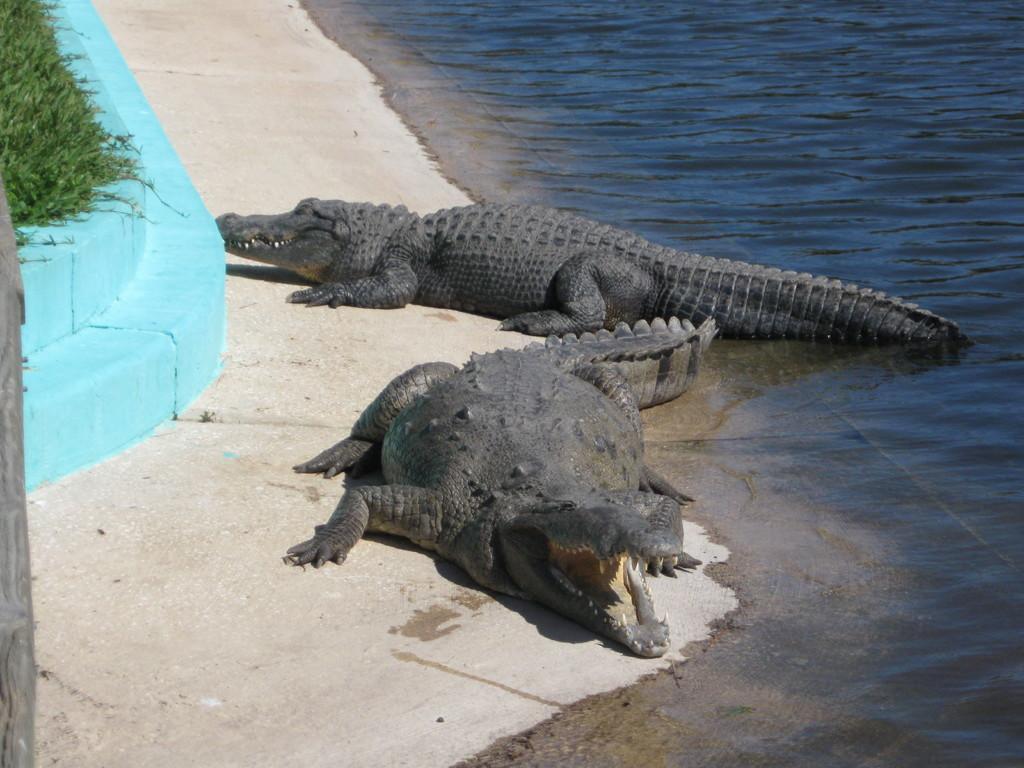How would you summarize this image in a sentence or two? In the center of the image, we can see crocodiles and in the background, there is water and we can see grass and a wall. 